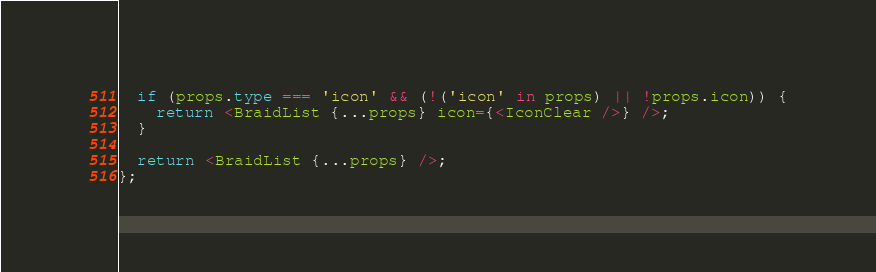<code> <loc_0><loc_0><loc_500><loc_500><_TypeScript_>  if (props.type === 'icon' && (!('icon' in props) || !props.icon)) {
    return <BraidList {...props} icon={<IconClear />} />;
  }

  return <BraidList {...props} />;
};
</code> 